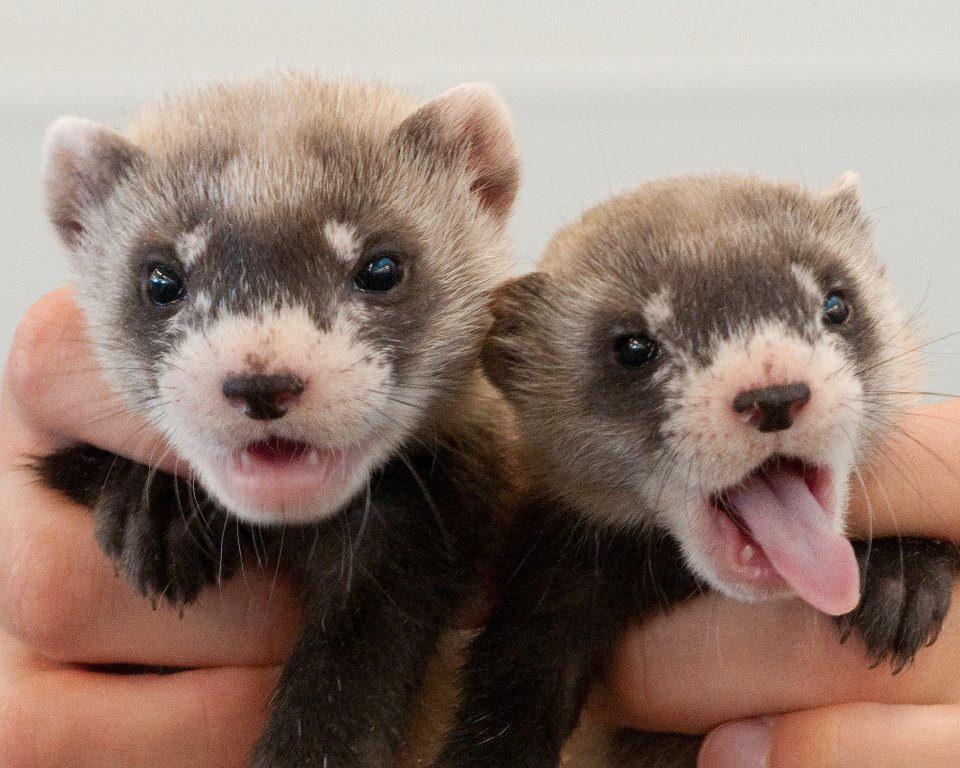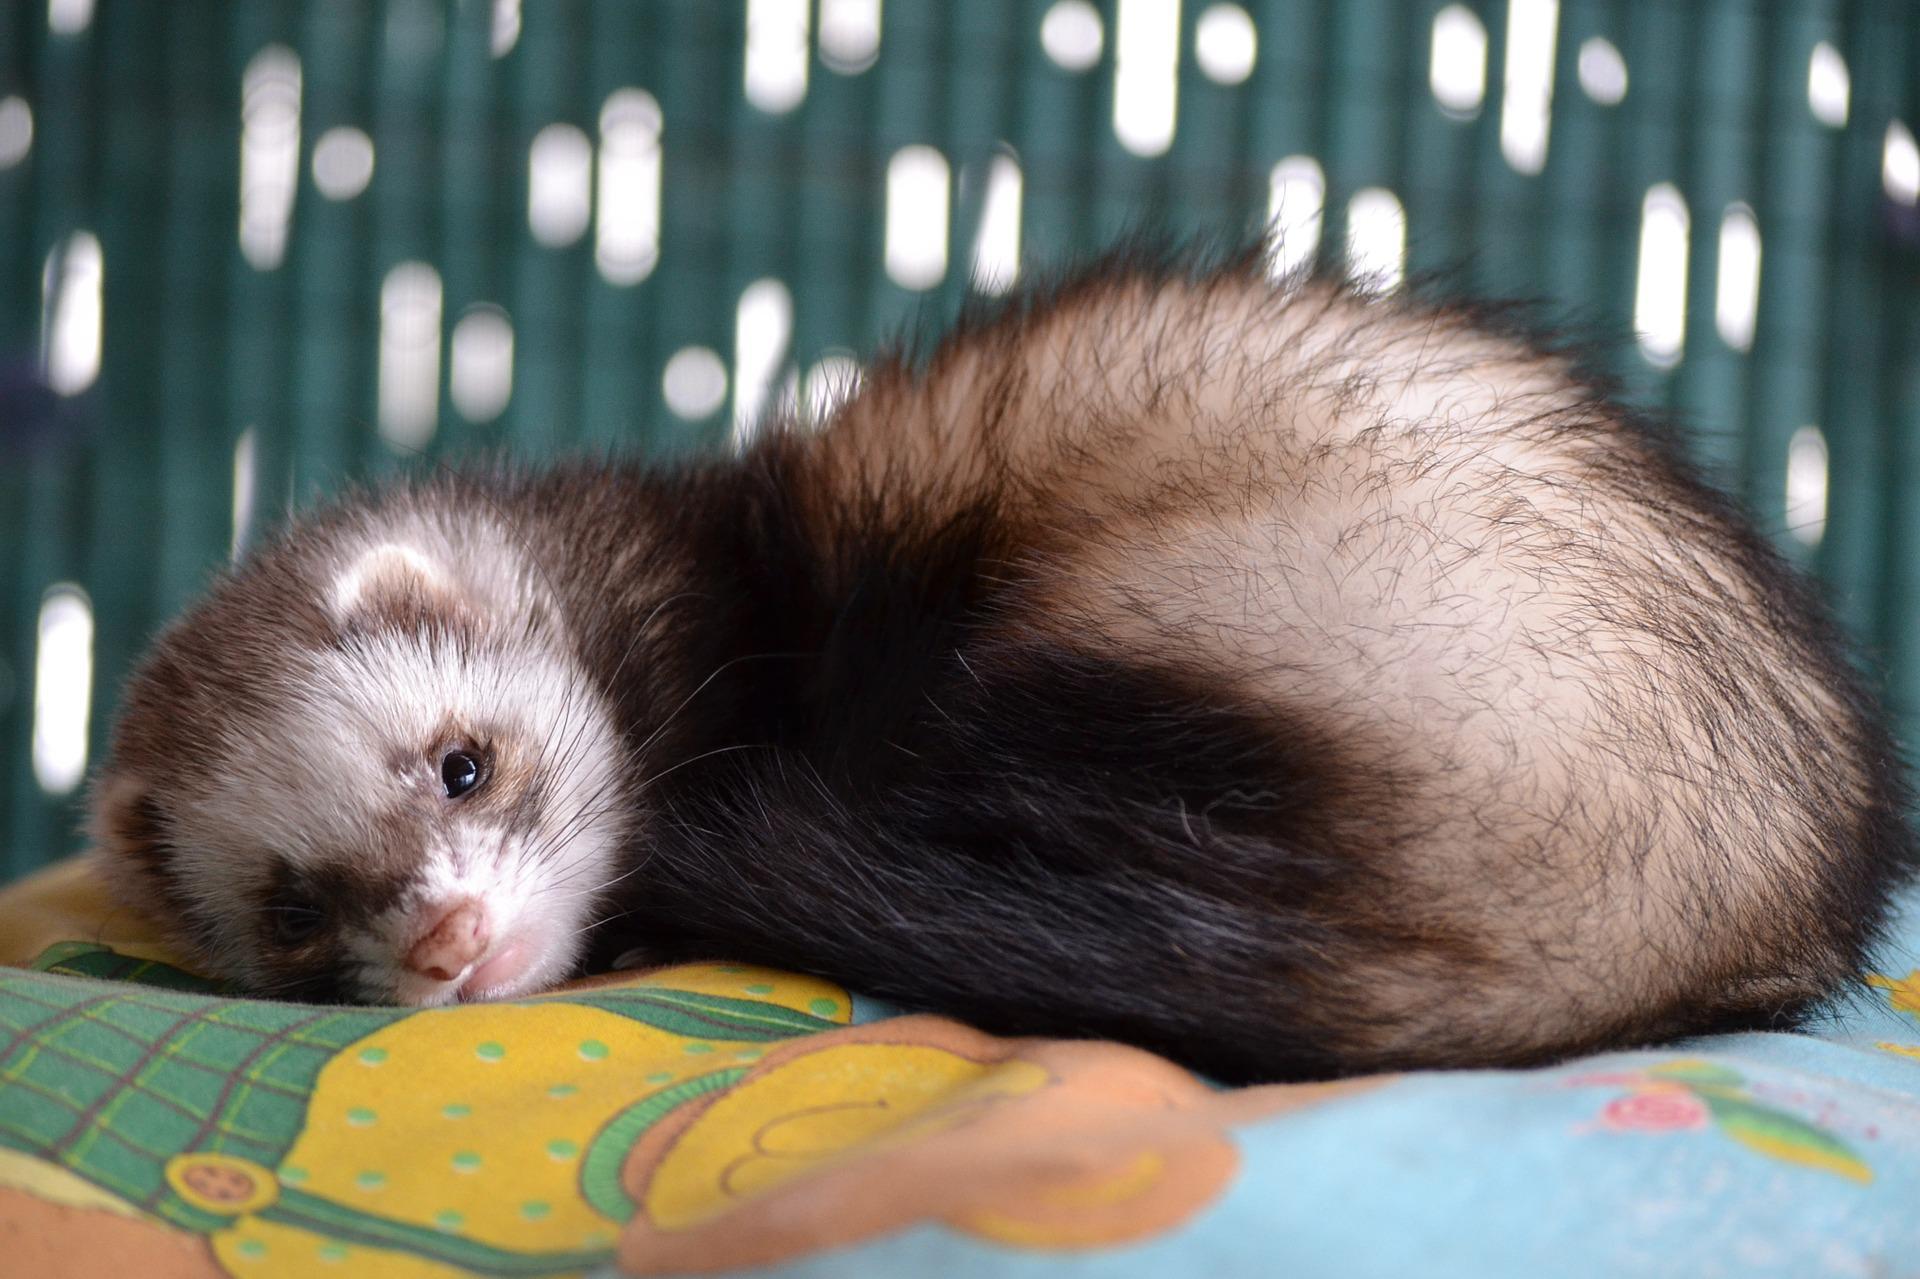The first image is the image on the left, the second image is the image on the right. Analyze the images presented: Is the assertion "The right image features a human hand holding a ferret." valid? Answer yes or no. No. 